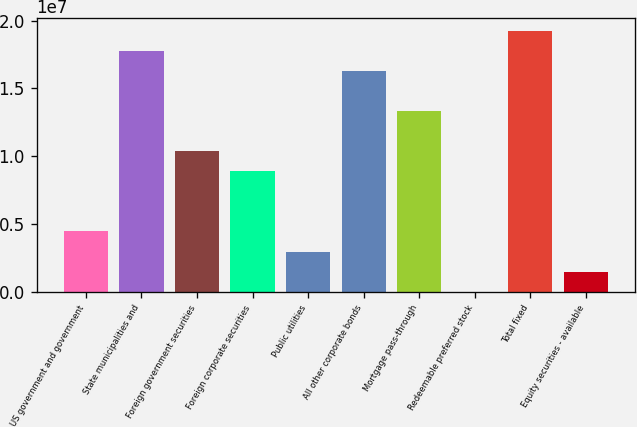Convert chart. <chart><loc_0><loc_0><loc_500><loc_500><bar_chart><fcel>US government and government<fcel>State municipalities and<fcel>Foreign government securities<fcel>Foreign corporate securities<fcel>Public utilities<fcel>All other corporate bonds<fcel>Mortgage pass-through<fcel>Redeemable preferred stock<fcel>Total fixed<fcel>Equity securities - available<nl><fcel>4.45291e+06<fcel>1.77617e+07<fcel>1.03679e+07<fcel>8.88916e+06<fcel>2.97416e+06<fcel>1.62829e+07<fcel>1.33254e+07<fcel>16654<fcel>1.92404e+07<fcel>1.49541e+06<nl></chart> 